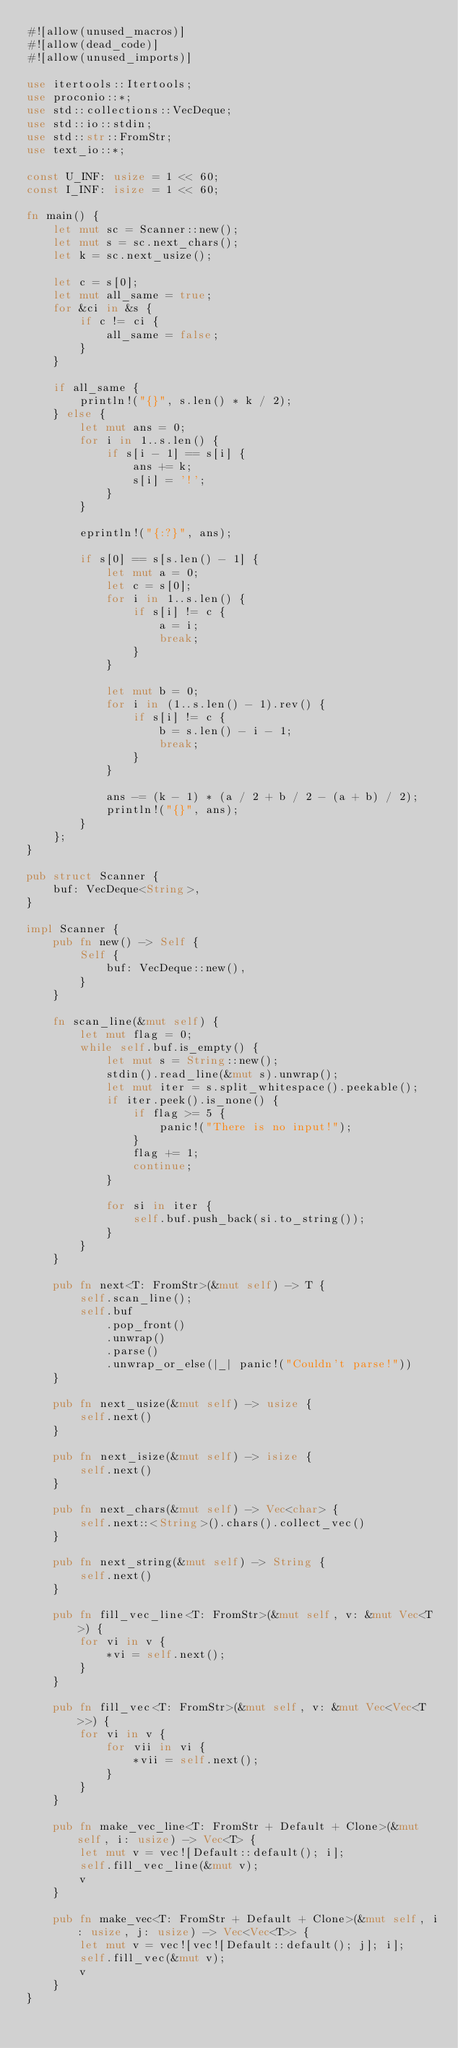<code> <loc_0><loc_0><loc_500><loc_500><_Rust_>#![allow(unused_macros)]
#![allow(dead_code)]
#![allow(unused_imports)]

use itertools::Itertools;
use proconio::*;
use std::collections::VecDeque;
use std::io::stdin;
use std::str::FromStr;
use text_io::*;

const U_INF: usize = 1 << 60;
const I_INF: isize = 1 << 60;

fn main() {
    let mut sc = Scanner::new();
    let mut s = sc.next_chars();
    let k = sc.next_usize();

    let c = s[0];
    let mut all_same = true;
    for &ci in &s {
        if c != ci {
            all_same = false;
        }
    }

    if all_same {
        println!("{}", s.len() * k / 2);
    } else {
        let mut ans = 0;
        for i in 1..s.len() {
            if s[i - 1] == s[i] {
                ans += k;
                s[i] = '!';
            }
        }
    
        eprintln!("{:?}", ans);
    
        if s[0] == s[s.len() - 1] {
            let mut a = 0;
            let c = s[0];
            for i in 1..s.len() {
                if s[i] != c {
                    a = i;
                    break;
                }
            }

            let mut b = 0;
            for i in (1..s.len() - 1).rev() {
                if s[i] != c {
                    b = s.len() - i - 1;
                    break;
                }
            }

            ans -= (k - 1) * (a / 2 + b / 2 - (a + b) / 2);
            println!("{}", ans);
        }
    };
}

pub struct Scanner {
    buf: VecDeque<String>,
}

impl Scanner {
    pub fn new() -> Self {
        Self {
            buf: VecDeque::new(),
        }
    }

    fn scan_line(&mut self) {
        let mut flag = 0;
        while self.buf.is_empty() {
            let mut s = String::new();
            stdin().read_line(&mut s).unwrap();
            let mut iter = s.split_whitespace().peekable();
            if iter.peek().is_none() {
                if flag >= 5 {
                    panic!("There is no input!");
                }
                flag += 1;
                continue;
            }

            for si in iter {
                self.buf.push_back(si.to_string());
            }
        }
    }

    pub fn next<T: FromStr>(&mut self) -> T {
        self.scan_line();
        self.buf
            .pop_front()
            .unwrap()
            .parse()
            .unwrap_or_else(|_| panic!("Couldn't parse!"))
    }

    pub fn next_usize(&mut self) -> usize {
        self.next()
    }

    pub fn next_isize(&mut self) -> isize {
        self.next()
    }

    pub fn next_chars(&mut self) -> Vec<char> {
        self.next::<String>().chars().collect_vec()
    }

    pub fn next_string(&mut self) -> String {
        self.next()
    }

    pub fn fill_vec_line<T: FromStr>(&mut self, v: &mut Vec<T>) {
        for vi in v {
            *vi = self.next();
        }
    }

    pub fn fill_vec<T: FromStr>(&mut self, v: &mut Vec<Vec<T>>) {
        for vi in v {
            for vii in vi {
                *vii = self.next();
            }
        }
    }

    pub fn make_vec_line<T: FromStr + Default + Clone>(&mut self, i: usize) -> Vec<T> {
        let mut v = vec![Default::default(); i];
        self.fill_vec_line(&mut v);
        v
    }

    pub fn make_vec<T: FromStr + Default + Clone>(&mut self, i: usize, j: usize) -> Vec<Vec<T>> {
        let mut v = vec![vec![Default::default(); j]; i];
        self.fill_vec(&mut v);
        v
    }
}
</code> 